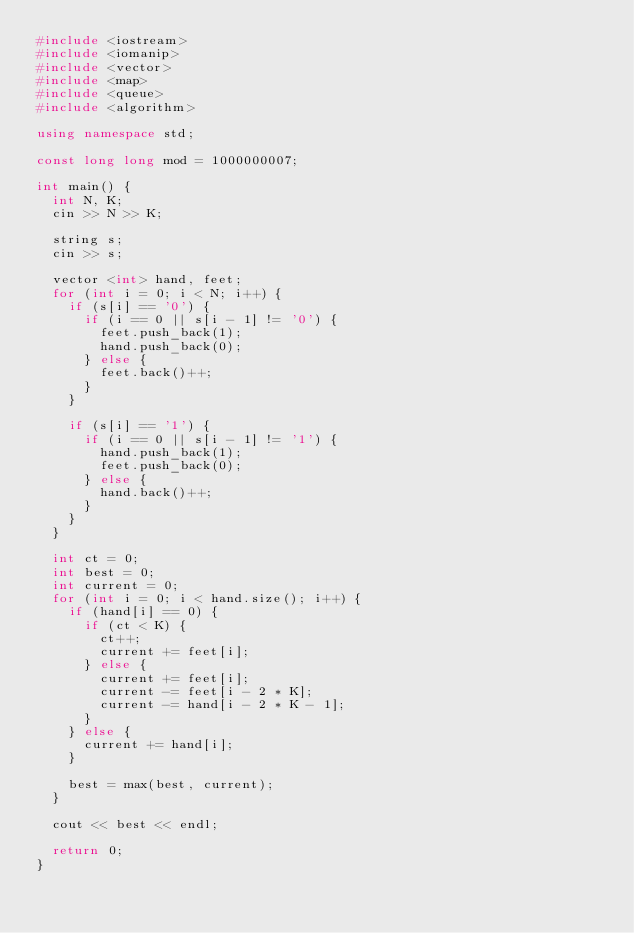Convert code to text. <code><loc_0><loc_0><loc_500><loc_500><_C++_>#include <iostream>
#include <iomanip>
#include <vector>
#include <map>
#include <queue>
#include <algorithm>

using namespace std;

const long long mod = 1000000007;

int main() {
  int N, K;
  cin >> N >> K;

  string s;
  cin >> s;

  vector <int> hand, feet;
  for (int i = 0; i < N; i++) {
    if (s[i] == '0') {
      if (i == 0 || s[i - 1] != '0') {
        feet.push_back(1);
        hand.push_back(0);
      } else {
        feet.back()++;
      }
    }

    if (s[i] == '1') {
      if (i == 0 || s[i - 1] != '1') {
        hand.push_back(1);
        feet.push_back(0);
      } else {
        hand.back()++;
      }
    }
  }

  int ct = 0;
  int best = 0;
  int current = 0;
  for (int i = 0; i < hand.size(); i++) {
    if (hand[i] == 0) {
      if (ct < K) {
        ct++;
        current += feet[i];
      } else {
        current += feet[i];
        current -= feet[i - 2 * K];
        current -= hand[i - 2 * K - 1];
      }
    } else {
      current += hand[i];
    }

    best = max(best, current);
  }

  cout << best << endl;

  return 0;
}
</code> 